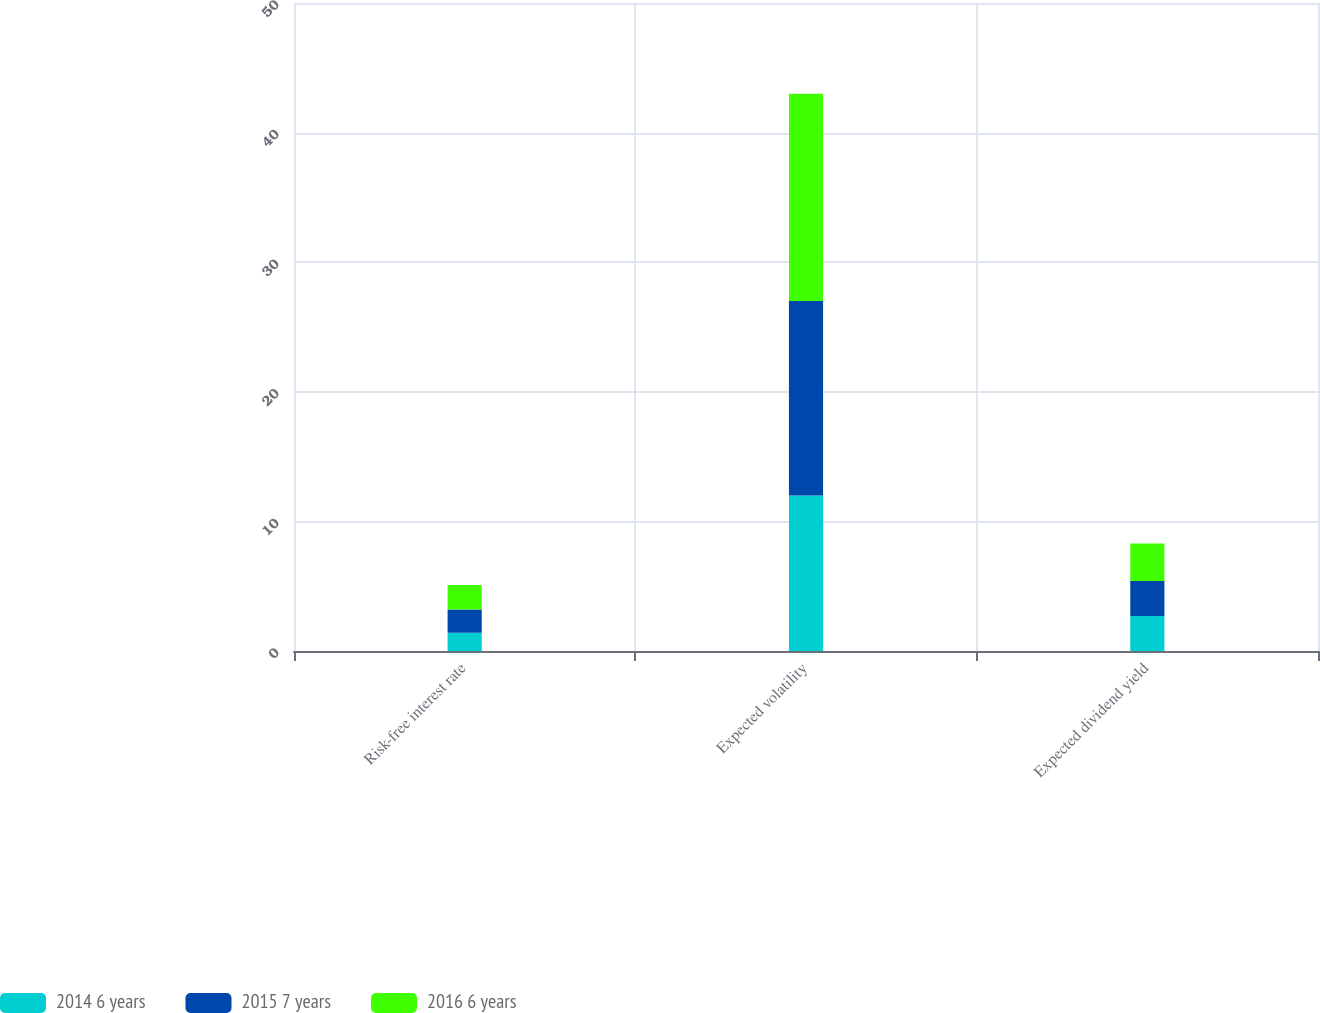Convert chart. <chart><loc_0><loc_0><loc_500><loc_500><stacked_bar_chart><ecel><fcel>Risk-free interest rate<fcel>Expected volatility<fcel>Expected dividend yield<nl><fcel>2014 6 years<fcel>1.4<fcel>12<fcel>2.7<nl><fcel>2015 7 years<fcel>1.8<fcel>15<fcel>2.7<nl><fcel>2016 6 years<fcel>1.9<fcel>16<fcel>2.9<nl></chart> 